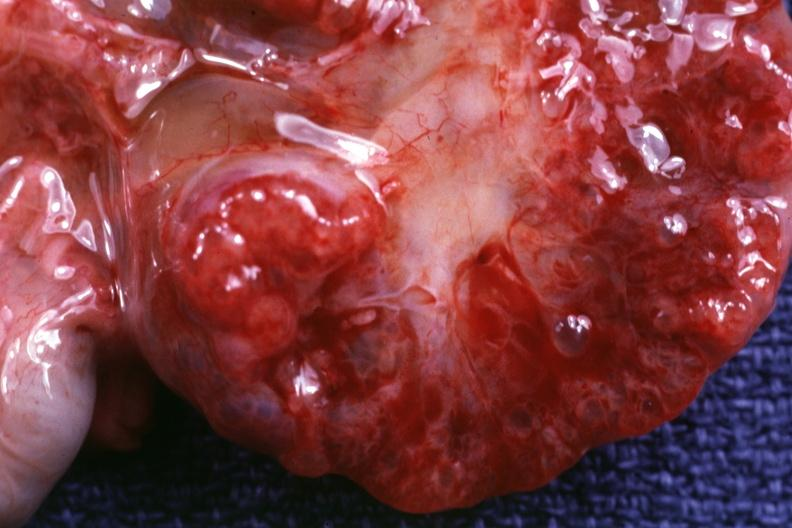s ulcerative lesion present?
Answer the question using a single word or phrase. No 